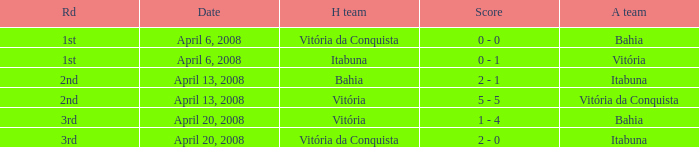Who was the home team on April 13, 2008 when Itabuna was the away team? Bahia. 